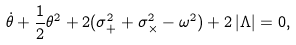<formula> <loc_0><loc_0><loc_500><loc_500>\dot { \theta } + \frac { 1 } { 2 } { \theta ^ { 2 } } + 2 ( \sigma _ { + } ^ { 2 } + \sigma _ { \times } ^ { 2 } - \omega ^ { 2 } ) + 2 \, | \Lambda | = 0 ,</formula> 